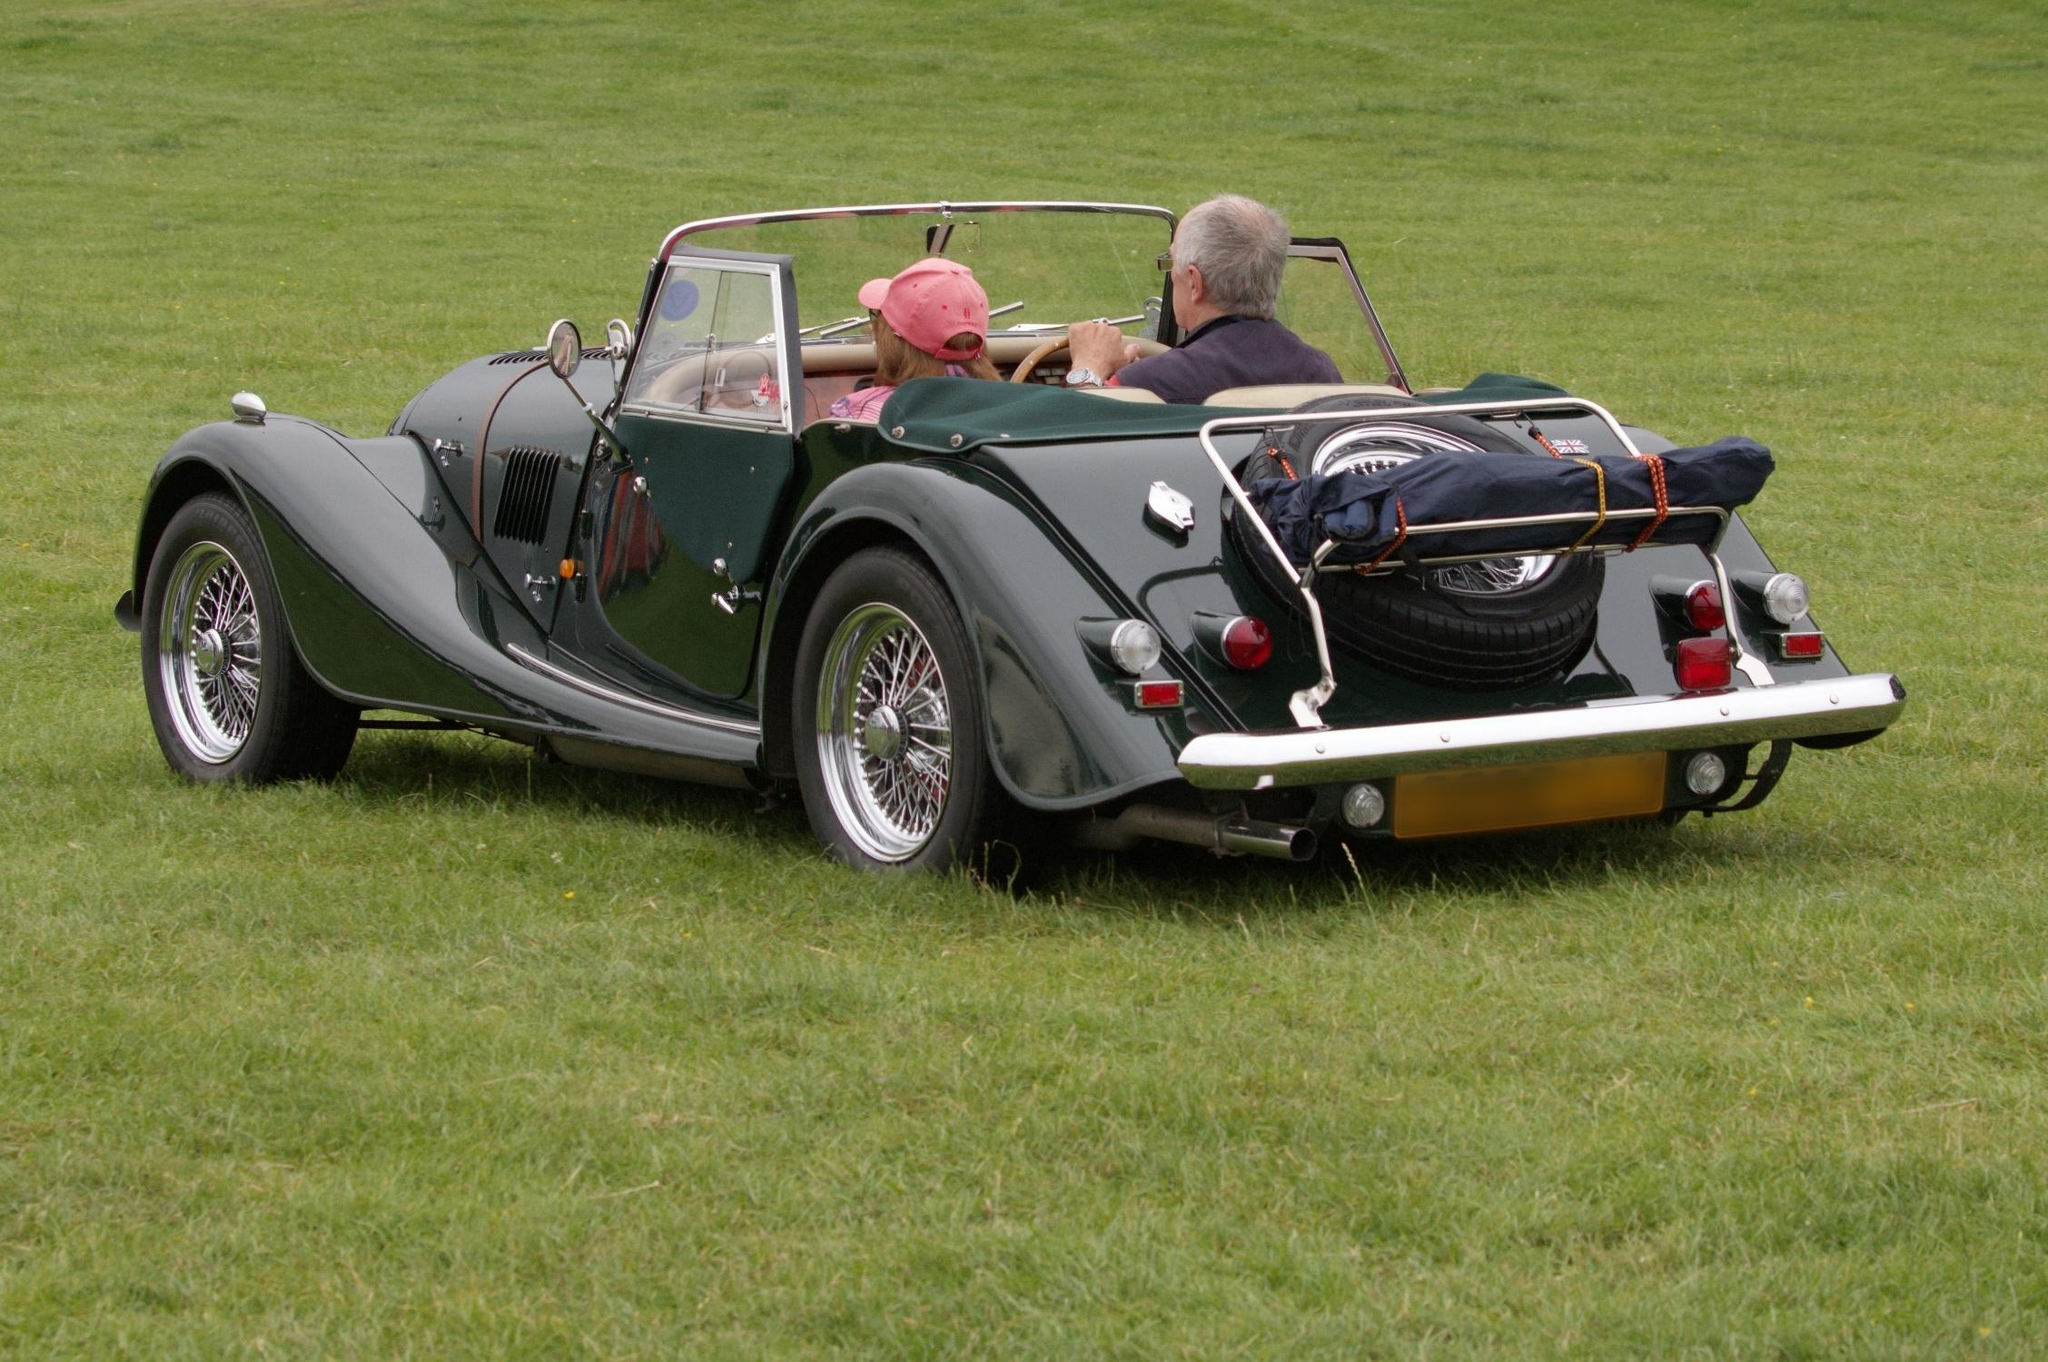What do you see happening in this image? The image captures a scene of a vintage car, elegantly painted in a beautiful green shade, parked on a lush grassy field. This classic car, with its tan convertible top folded down, radiates a nostalgic charm. The car is adorned with wire wheels and a spare tire mounted on the back, evoking a bygone era of automotive design. It is meticulously maintained, with its polished exterior gleaming in the sunlight.

Inside the car, two individuals are seated - one in the driver's seat and the other in the passenger's seat - appearing ready to embark on a leisurely drive. The composition of the image, taken from a slightly elevated angle, offers a clear and comprehensive view of the car and its occupants against the serene backdrop of the expansive field. This moment, captured beautifully, tells a story of carefree enjoyment and the timeless allure of classic cars. 